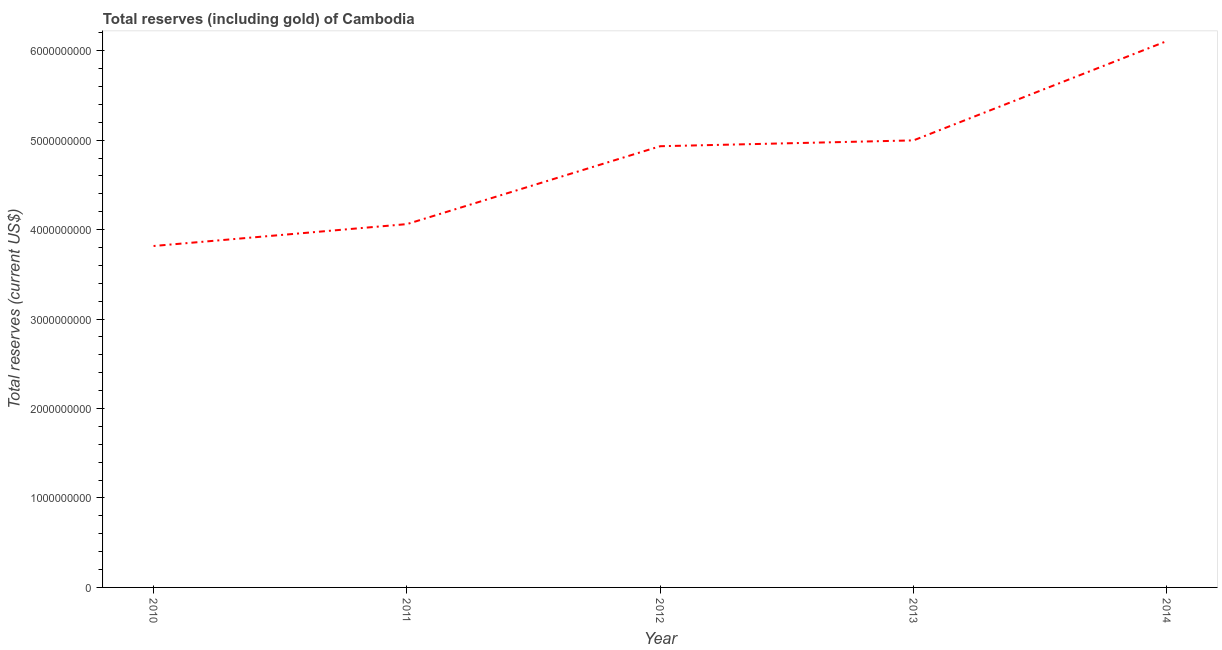What is the total reserves (including gold) in 2014?
Your response must be concise. 6.11e+09. Across all years, what is the maximum total reserves (including gold)?
Keep it short and to the point. 6.11e+09. Across all years, what is the minimum total reserves (including gold)?
Your response must be concise. 3.82e+09. What is the sum of the total reserves (including gold)?
Keep it short and to the point. 2.39e+1. What is the difference between the total reserves (including gold) in 2012 and 2013?
Offer a very short reply. -6.52e+07. What is the average total reserves (including gold) per year?
Make the answer very short. 4.78e+09. What is the median total reserves (including gold)?
Make the answer very short. 4.93e+09. What is the ratio of the total reserves (including gold) in 2012 to that in 2013?
Your answer should be compact. 0.99. Is the total reserves (including gold) in 2011 less than that in 2012?
Give a very brief answer. Yes. Is the difference between the total reserves (including gold) in 2010 and 2014 greater than the difference between any two years?
Give a very brief answer. Yes. What is the difference between the highest and the second highest total reserves (including gold)?
Make the answer very short. 1.11e+09. Is the sum of the total reserves (including gold) in 2011 and 2013 greater than the maximum total reserves (including gold) across all years?
Your response must be concise. Yes. What is the difference between the highest and the lowest total reserves (including gold)?
Your answer should be very brief. 2.29e+09. In how many years, is the total reserves (including gold) greater than the average total reserves (including gold) taken over all years?
Provide a succinct answer. 3. How many years are there in the graph?
Offer a very short reply. 5. Are the values on the major ticks of Y-axis written in scientific E-notation?
Give a very brief answer. No. Does the graph contain grids?
Offer a very short reply. No. What is the title of the graph?
Ensure brevity in your answer.  Total reserves (including gold) of Cambodia. What is the label or title of the X-axis?
Your response must be concise. Year. What is the label or title of the Y-axis?
Your response must be concise. Total reserves (current US$). What is the Total reserves (current US$) of 2010?
Give a very brief answer. 3.82e+09. What is the Total reserves (current US$) in 2011?
Offer a very short reply. 4.06e+09. What is the Total reserves (current US$) of 2012?
Your answer should be very brief. 4.93e+09. What is the Total reserves (current US$) of 2013?
Provide a short and direct response. 5.00e+09. What is the Total reserves (current US$) in 2014?
Keep it short and to the point. 6.11e+09. What is the difference between the Total reserves (current US$) in 2010 and 2011?
Your answer should be compact. -2.45e+08. What is the difference between the Total reserves (current US$) in 2010 and 2012?
Ensure brevity in your answer.  -1.12e+09. What is the difference between the Total reserves (current US$) in 2010 and 2013?
Make the answer very short. -1.18e+09. What is the difference between the Total reserves (current US$) in 2010 and 2014?
Provide a short and direct response. -2.29e+09. What is the difference between the Total reserves (current US$) in 2011 and 2012?
Ensure brevity in your answer.  -8.71e+08. What is the difference between the Total reserves (current US$) in 2011 and 2013?
Your response must be concise. -9.36e+08. What is the difference between the Total reserves (current US$) in 2011 and 2014?
Make the answer very short. -2.05e+09. What is the difference between the Total reserves (current US$) in 2012 and 2013?
Keep it short and to the point. -6.52e+07. What is the difference between the Total reserves (current US$) in 2012 and 2014?
Your response must be concise. -1.18e+09. What is the difference between the Total reserves (current US$) in 2013 and 2014?
Offer a terse response. -1.11e+09. What is the ratio of the Total reserves (current US$) in 2010 to that in 2011?
Ensure brevity in your answer.  0.94. What is the ratio of the Total reserves (current US$) in 2010 to that in 2012?
Ensure brevity in your answer.  0.77. What is the ratio of the Total reserves (current US$) in 2010 to that in 2013?
Keep it short and to the point. 0.76. What is the ratio of the Total reserves (current US$) in 2010 to that in 2014?
Keep it short and to the point. 0.62. What is the ratio of the Total reserves (current US$) in 2011 to that in 2012?
Make the answer very short. 0.82. What is the ratio of the Total reserves (current US$) in 2011 to that in 2013?
Make the answer very short. 0.81. What is the ratio of the Total reserves (current US$) in 2011 to that in 2014?
Your response must be concise. 0.67. What is the ratio of the Total reserves (current US$) in 2012 to that in 2013?
Keep it short and to the point. 0.99. What is the ratio of the Total reserves (current US$) in 2012 to that in 2014?
Offer a very short reply. 0.81. What is the ratio of the Total reserves (current US$) in 2013 to that in 2014?
Provide a succinct answer. 0.82. 